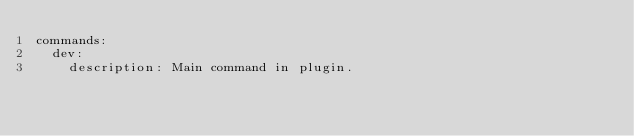Convert code to text. <code><loc_0><loc_0><loc_500><loc_500><_YAML_>commands:
  dev:
    description: Main command in plugin.
</code> 